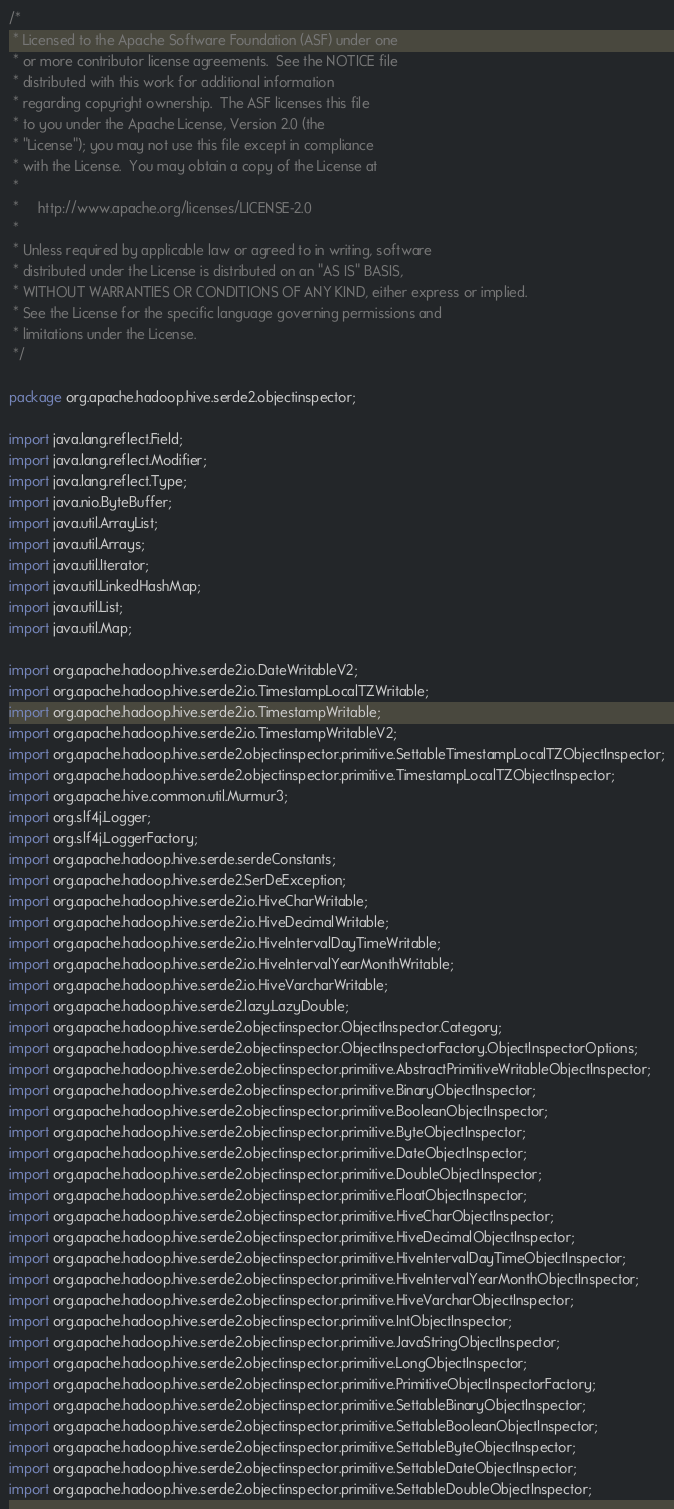<code> <loc_0><loc_0><loc_500><loc_500><_Java_>/*
 * Licensed to the Apache Software Foundation (ASF) under one
 * or more contributor license agreements.  See the NOTICE file
 * distributed with this work for additional information
 * regarding copyright ownership.  The ASF licenses this file
 * to you under the Apache License, Version 2.0 (the
 * "License"); you may not use this file except in compliance
 * with the License.  You may obtain a copy of the License at
 *
 *     http://www.apache.org/licenses/LICENSE-2.0
 *
 * Unless required by applicable law or agreed to in writing, software
 * distributed under the License is distributed on an "AS IS" BASIS,
 * WITHOUT WARRANTIES OR CONDITIONS OF ANY KIND, either express or implied.
 * See the License for the specific language governing permissions and
 * limitations under the License.
 */

package org.apache.hadoop.hive.serde2.objectinspector;

import java.lang.reflect.Field;
import java.lang.reflect.Modifier;
import java.lang.reflect.Type;
import java.nio.ByteBuffer;
import java.util.ArrayList;
import java.util.Arrays;
import java.util.Iterator;
import java.util.LinkedHashMap;
import java.util.List;
import java.util.Map;

import org.apache.hadoop.hive.serde2.io.DateWritableV2;
import org.apache.hadoop.hive.serde2.io.TimestampLocalTZWritable;
import org.apache.hadoop.hive.serde2.io.TimestampWritable;
import org.apache.hadoop.hive.serde2.io.TimestampWritableV2;
import org.apache.hadoop.hive.serde2.objectinspector.primitive.SettableTimestampLocalTZObjectInspector;
import org.apache.hadoop.hive.serde2.objectinspector.primitive.TimestampLocalTZObjectInspector;
import org.apache.hive.common.util.Murmur3;
import org.slf4j.Logger;
import org.slf4j.LoggerFactory;
import org.apache.hadoop.hive.serde.serdeConstants;
import org.apache.hadoop.hive.serde2.SerDeException;
import org.apache.hadoop.hive.serde2.io.HiveCharWritable;
import org.apache.hadoop.hive.serde2.io.HiveDecimalWritable;
import org.apache.hadoop.hive.serde2.io.HiveIntervalDayTimeWritable;
import org.apache.hadoop.hive.serde2.io.HiveIntervalYearMonthWritable;
import org.apache.hadoop.hive.serde2.io.HiveVarcharWritable;
import org.apache.hadoop.hive.serde2.lazy.LazyDouble;
import org.apache.hadoop.hive.serde2.objectinspector.ObjectInspector.Category;
import org.apache.hadoop.hive.serde2.objectinspector.ObjectInspectorFactory.ObjectInspectorOptions;
import org.apache.hadoop.hive.serde2.objectinspector.primitive.AbstractPrimitiveWritableObjectInspector;
import org.apache.hadoop.hive.serde2.objectinspector.primitive.BinaryObjectInspector;
import org.apache.hadoop.hive.serde2.objectinspector.primitive.BooleanObjectInspector;
import org.apache.hadoop.hive.serde2.objectinspector.primitive.ByteObjectInspector;
import org.apache.hadoop.hive.serde2.objectinspector.primitive.DateObjectInspector;
import org.apache.hadoop.hive.serde2.objectinspector.primitive.DoubleObjectInspector;
import org.apache.hadoop.hive.serde2.objectinspector.primitive.FloatObjectInspector;
import org.apache.hadoop.hive.serde2.objectinspector.primitive.HiveCharObjectInspector;
import org.apache.hadoop.hive.serde2.objectinspector.primitive.HiveDecimalObjectInspector;
import org.apache.hadoop.hive.serde2.objectinspector.primitive.HiveIntervalDayTimeObjectInspector;
import org.apache.hadoop.hive.serde2.objectinspector.primitive.HiveIntervalYearMonthObjectInspector;
import org.apache.hadoop.hive.serde2.objectinspector.primitive.HiveVarcharObjectInspector;
import org.apache.hadoop.hive.serde2.objectinspector.primitive.IntObjectInspector;
import org.apache.hadoop.hive.serde2.objectinspector.primitive.JavaStringObjectInspector;
import org.apache.hadoop.hive.serde2.objectinspector.primitive.LongObjectInspector;
import org.apache.hadoop.hive.serde2.objectinspector.primitive.PrimitiveObjectInspectorFactory;
import org.apache.hadoop.hive.serde2.objectinspector.primitive.SettableBinaryObjectInspector;
import org.apache.hadoop.hive.serde2.objectinspector.primitive.SettableBooleanObjectInspector;
import org.apache.hadoop.hive.serde2.objectinspector.primitive.SettableByteObjectInspector;
import org.apache.hadoop.hive.serde2.objectinspector.primitive.SettableDateObjectInspector;
import org.apache.hadoop.hive.serde2.objectinspector.primitive.SettableDoubleObjectInspector;</code> 